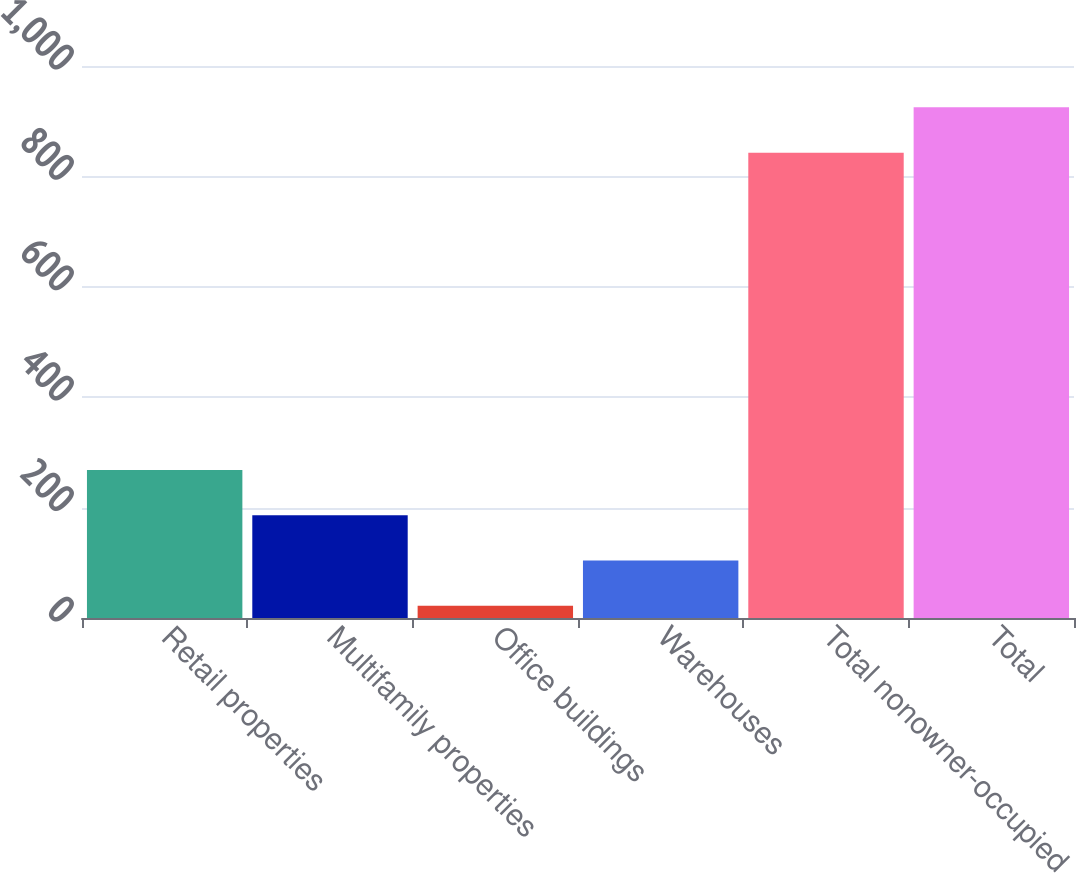Convert chart to OTSL. <chart><loc_0><loc_0><loc_500><loc_500><bar_chart><fcel>Retail properties<fcel>Multifamily properties<fcel>Office buildings<fcel>Warehouses<fcel>Total nonowner-occupied<fcel>Total<nl><fcel>268.3<fcel>186.2<fcel>22<fcel>104.1<fcel>843<fcel>925.1<nl></chart> 